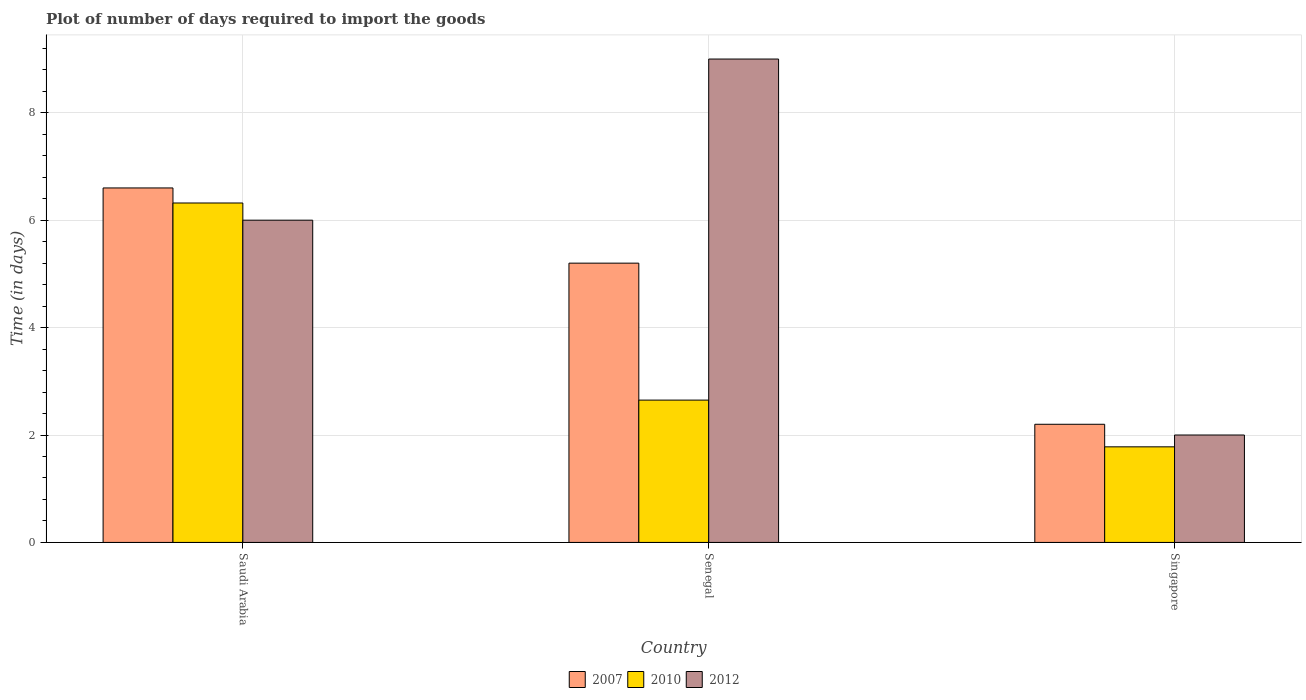How many groups of bars are there?
Offer a very short reply. 3. How many bars are there on the 3rd tick from the left?
Offer a terse response. 3. How many bars are there on the 3rd tick from the right?
Keep it short and to the point. 3. What is the label of the 3rd group of bars from the left?
Offer a terse response. Singapore. In how many cases, is the number of bars for a given country not equal to the number of legend labels?
Provide a short and direct response. 0. What is the time required to import goods in 2010 in Singapore?
Ensure brevity in your answer.  1.78. Across all countries, what is the maximum time required to import goods in 2012?
Your response must be concise. 9. Across all countries, what is the minimum time required to import goods in 2007?
Give a very brief answer. 2.2. In which country was the time required to import goods in 2010 maximum?
Make the answer very short. Saudi Arabia. In which country was the time required to import goods in 2007 minimum?
Provide a short and direct response. Singapore. What is the difference between the time required to import goods in 2010 in Senegal and that in Singapore?
Provide a short and direct response. 0.87. What is the difference between the time required to import goods in 2010 in Singapore and the time required to import goods in 2012 in Senegal?
Your answer should be very brief. -7.22. What is the average time required to import goods in 2007 per country?
Offer a very short reply. 4.67. What is the difference between the time required to import goods of/in 2010 and time required to import goods of/in 2007 in Senegal?
Offer a very short reply. -2.55. What is the ratio of the time required to import goods in 2012 in Senegal to that in Singapore?
Provide a short and direct response. 4.5. Is the time required to import goods in 2012 in Saudi Arabia less than that in Senegal?
Provide a short and direct response. Yes. What does the 1st bar from the left in Singapore represents?
Your response must be concise. 2007. What does the 2nd bar from the right in Singapore represents?
Make the answer very short. 2010. Are all the bars in the graph horizontal?
Provide a short and direct response. No. How many countries are there in the graph?
Ensure brevity in your answer.  3. What is the difference between two consecutive major ticks on the Y-axis?
Your answer should be compact. 2. Are the values on the major ticks of Y-axis written in scientific E-notation?
Ensure brevity in your answer.  No. Where does the legend appear in the graph?
Ensure brevity in your answer.  Bottom center. How many legend labels are there?
Provide a short and direct response. 3. How are the legend labels stacked?
Your answer should be very brief. Horizontal. What is the title of the graph?
Keep it short and to the point. Plot of number of days required to import the goods. Does "2006" appear as one of the legend labels in the graph?
Provide a succinct answer. No. What is the label or title of the X-axis?
Offer a terse response. Country. What is the label or title of the Y-axis?
Your response must be concise. Time (in days). What is the Time (in days) of 2007 in Saudi Arabia?
Your answer should be very brief. 6.6. What is the Time (in days) of 2010 in Saudi Arabia?
Give a very brief answer. 6.32. What is the Time (in days) of 2012 in Saudi Arabia?
Your answer should be compact. 6. What is the Time (in days) in 2007 in Senegal?
Offer a very short reply. 5.2. What is the Time (in days) of 2010 in Senegal?
Provide a succinct answer. 2.65. What is the Time (in days) of 2007 in Singapore?
Your answer should be compact. 2.2. What is the Time (in days) of 2010 in Singapore?
Offer a very short reply. 1.78. Across all countries, what is the maximum Time (in days) in 2010?
Offer a terse response. 6.32. Across all countries, what is the minimum Time (in days) in 2010?
Your answer should be very brief. 1.78. What is the total Time (in days) of 2010 in the graph?
Your answer should be very brief. 10.75. What is the difference between the Time (in days) of 2010 in Saudi Arabia and that in Senegal?
Ensure brevity in your answer.  3.67. What is the difference between the Time (in days) of 2012 in Saudi Arabia and that in Senegal?
Keep it short and to the point. -3. What is the difference between the Time (in days) of 2010 in Saudi Arabia and that in Singapore?
Your answer should be compact. 4.54. What is the difference between the Time (in days) in 2010 in Senegal and that in Singapore?
Make the answer very short. 0.87. What is the difference between the Time (in days) of 2007 in Saudi Arabia and the Time (in days) of 2010 in Senegal?
Offer a very short reply. 3.95. What is the difference between the Time (in days) in 2010 in Saudi Arabia and the Time (in days) in 2012 in Senegal?
Provide a succinct answer. -2.68. What is the difference between the Time (in days) in 2007 in Saudi Arabia and the Time (in days) in 2010 in Singapore?
Make the answer very short. 4.82. What is the difference between the Time (in days) in 2010 in Saudi Arabia and the Time (in days) in 2012 in Singapore?
Give a very brief answer. 4.32. What is the difference between the Time (in days) in 2007 in Senegal and the Time (in days) in 2010 in Singapore?
Keep it short and to the point. 3.42. What is the difference between the Time (in days) of 2007 in Senegal and the Time (in days) of 2012 in Singapore?
Ensure brevity in your answer.  3.2. What is the difference between the Time (in days) of 2010 in Senegal and the Time (in days) of 2012 in Singapore?
Ensure brevity in your answer.  0.65. What is the average Time (in days) in 2007 per country?
Give a very brief answer. 4.67. What is the average Time (in days) in 2010 per country?
Offer a very short reply. 3.58. What is the average Time (in days) in 2012 per country?
Provide a short and direct response. 5.67. What is the difference between the Time (in days) in 2007 and Time (in days) in 2010 in Saudi Arabia?
Your answer should be compact. 0.28. What is the difference between the Time (in days) in 2007 and Time (in days) in 2012 in Saudi Arabia?
Ensure brevity in your answer.  0.6. What is the difference between the Time (in days) in 2010 and Time (in days) in 2012 in Saudi Arabia?
Your response must be concise. 0.32. What is the difference between the Time (in days) of 2007 and Time (in days) of 2010 in Senegal?
Give a very brief answer. 2.55. What is the difference between the Time (in days) in 2007 and Time (in days) in 2012 in Senegal?
Keep it short and to the point. -3.8. What is the difference between the Time (in days) of 2010 and Time (in days) of 2012 in Senegal?
Offer a terse response. -6.35. What is the difference between the Time (in days) in 2007 and Time (in days) in 2010 in Singapore?
Ensure brevity in your answer.  0.42. What is the difference between the Time (in days) in 2010 and Time (in days) in 2012 in Singapore?
Your answer should be compact. -0.22. What is the ratio of the Time (in days) of 2007 in Saudi Arabia to that in Senegal?
Offer a terse response. 1.27. What is the ratio of the Time (in days) in 2010 in Saudi Arabia to that in Senegal?
Give a very brief answer. 2.38. What is the ratio of the Time (in days) in 2012 in Saudi Arabia to that in Senegal?
Make the answer very short. 0.67. What is the ratio of the Time (in days) in 2007 in Saudi Arabia to that in Singapore?
Provide a succinct answer. 3. What is the ratio of the Time (in days) in 2010 in Saudi Arabia to that in Singapore?
Give a very brief answer. 3.55. What is the ratio of the Time (in days) of 2007 in Senegal to that in Singapore?
Provide a succinct answer. 2.36. What is the ratio of the Time (in days) in 2010 in Senegal to that in Singapore?
Provide a succinct answer. 1.49. What is the difference between the highest and the second highest Time (in days) in 2010?
Your response must be concise. 3.67. What is the difference between the highest and the second highest Time (in days) of 2012?
Provide a succinct answer. 3. What is the difference between the highest and the lowest Time (in days) in 2010?
Make the answer very short. 4.54. 